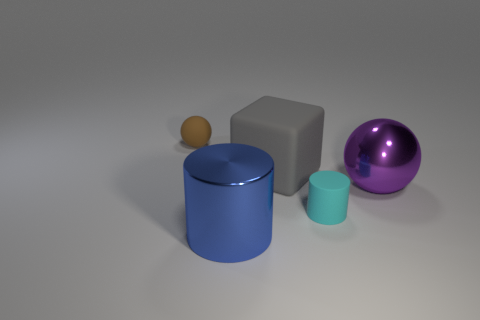What number of things are either shiny things that are on the right side of the blue cylinder or shiny things that are on the left side of the small matte cylinder?
Your answer should be compact. 2. What number of spheres are left of the metal thing that is behind the small object that is right of the large gray thing?
Give a very brief answer. 1. There is a ball on the right side of the small brown rubber thing; what is its size?
Provide a short and direct response. Large. What number of shiny cylinders have the same size as the rubber cylinder?
Provide a succinct answer. 0. There is a gray thing; is its size the same as the brown matte ball behind the large metal cylinder?
Offer a very short reply. No. How many objects are either small cyan objects or big red metal blocks?
Offer a terse response. 1. There is another shiny thing that is the same size as the purple object; what shape is it?
Your response must be concise. Cylinder. Are there any big blue things that have the same shape as the tiny cyan matte object?
Make the answer very short. Yes. How many big purple balls have the same material as the cyan cylinder?
Your answer should be compact. 0. Are the sphere that is in front of the small brown object and the large cylinder made of the same material?
Offer a very short reply. Yes. 